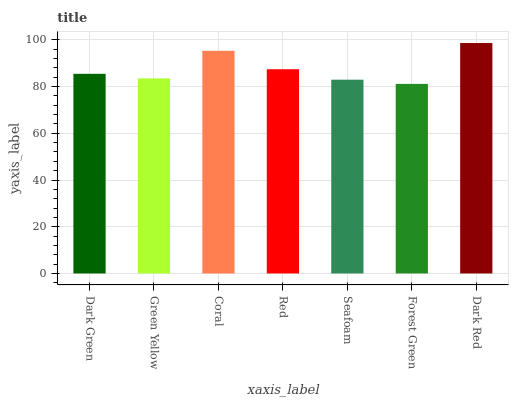Is Forest Green the minimum?
Answer yes or no. Yes. Is Dark Red the maximum?
Answer yes or no. Yes. Is Green Yellow the minimum?
Answer yes or no. No. Is Green Yellow the maximum?
Answer yes or no. No. Is Dark Green greater than Green Yellow?
Answer yes or no. Yes. Is Green Yellow less than Dark Green?
Answer yes or no. Yes. Is Green Yellow greater than Dark Green?
Answer yes or no. No. Is Dark Green less than Green Yellow?
Answer yes or no. No. Is Dark Green the high median?
Answer yes or no. Yes. Is Dark Green the low median?
Answer yes or no. Yes. Is Green Yellow the high median?
Answer yes or no. No. Is Forest Green the low median?
Answer yes or no. No. 